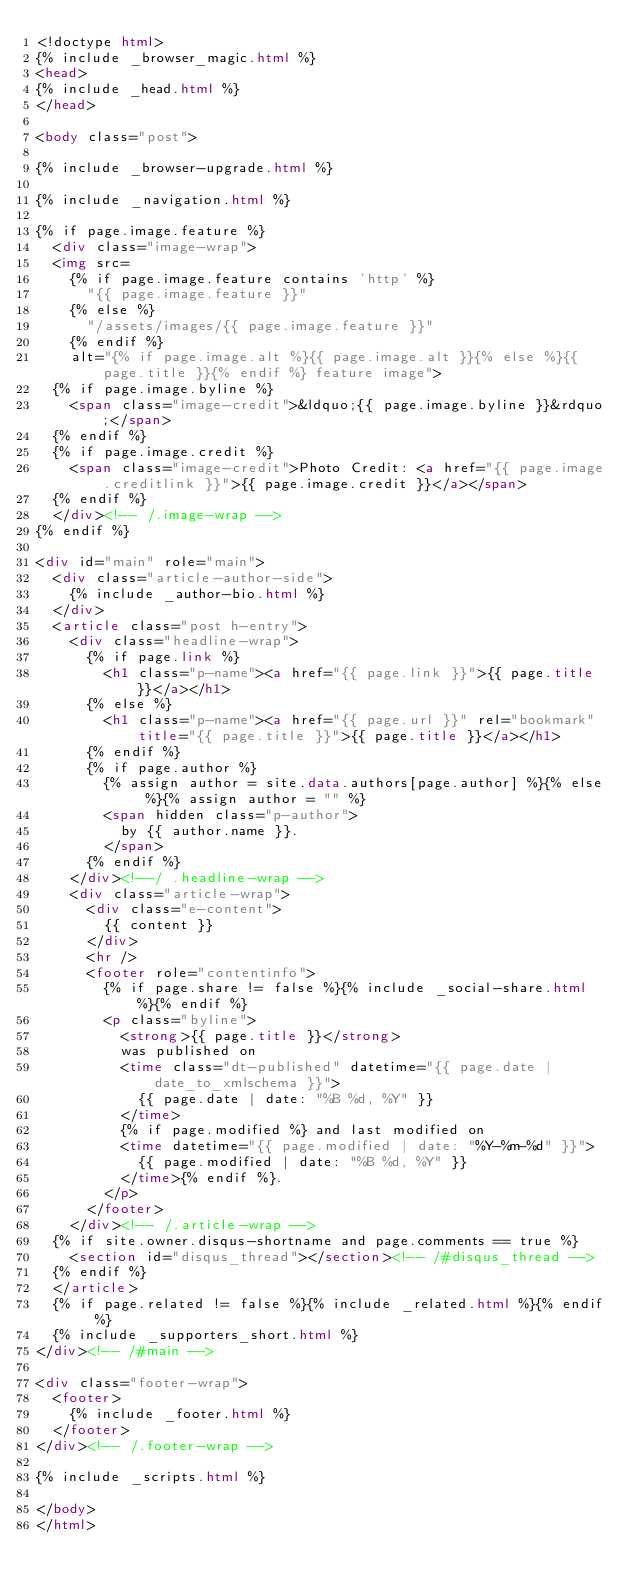<code> <loc_0><loc_0><loc_500><loc_500><_HTML_><!doctype html>
{% include _browser_magic.html %}
<head>
{% include _head.html %}
</head>

<body class="post">

{% include _browser-upgrade.html %}

{% include _navigation.html %}

{% if page.image.feature %}
  <div class="image-wrap">
  <img src=
    {% if page.image.feature contains 'http' %}
      "{{ page.image.feature }}"
    {% else %}
      "/assets/images/{{ page.image.feature }}"
    {% endif %}
    alt="{% if page.image.alt %}{{ page.image.alt }}{% else %}{{ page.title }}{% endif %} feature image">
  {% if page.image.byline %}
    <span class="image-credit">&ldquo;{{ page.image.byline }}&rdquo;</span>
  {% endif %}
  {% if page.image.credit %}
    <span class="image-credit">Photo Credit: <a href="{{ page.image.creditlink }}">{{ page.image.credit }}</a></span>
  {% endif %}
  </div><!-- /.image-wrap -->
{% endif %}

<div id="main" role="main">
  <div class="article-author-side">
    {% include _author-bio.html %}
  </div>
  <article class="post h-entry">
    <div class="headline-wrap">
      {% if page.link %}
        <h1 class="p-name"><a href="{{ page.link }}">{{ page.title }}</a></h1>
      {% else %}
        <h1 class="p-name"><a href="{{ page.url }}" rel="bookmark" title="{{ page.title }}">{{ page.title }}</a></h1>
      {% endif %}
      {% if page.author %}
        {% assign author = site.data.authors[page.author] %}{% else %}{% assign author = "" %}
        <span hidden class="p-author">
          by {{ author.name }}.
        </span>
      {% endif %}
    </div><!--/ .headline-wrap -->
    <div class="article-wrap">
      <div class="e-content">
        {{ content }}
      </div>
      <hr />
      <footer role="contentinfo">
        {% if page.share != false %}{% include _social-share.html %}{% endif %}
        <p class="byline">
          <strong>{{ page.title }}</strong>
          was published on
          <time class="dt-published" datetime="{{ page.date | date_to_xmlschema }}">
            {{ page.date | date: "%B %d, %Y" }}
          </time>
          {% if page.modified %} and last modified on
          <time datetime="{{ page.modified | date: "%Y-%m-%d" }}">
            {{ page.modified | date: "%B %d, %Y" }}
          </time>{% endif %}.
        </p>
      </footer>
    </div><!-- /.article-wrap -->
  {% if site.owner.disqus-shortname and page.comments == true %}
    <section id="disqus_thread"></section><!-- /#disqus_thread -->
  {% endif %}
  </article>
  {% if page.related != false %}{% include _related.html %}{% endif %}
  {% include _supporters_short.html %}
</div><!-- /#main -->

<div class="footer-wrap">
  <footer>
    {% include _footer.html %}
  </footer>
</div><!-- /.footer-wrap -->

{% include _scripts.html %}

</body>
</html>
</code> 